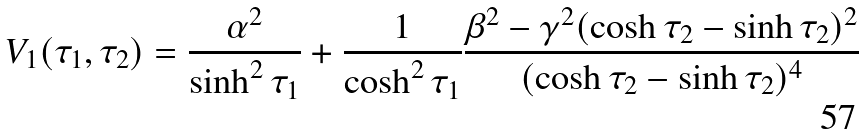Convert formula to latex. <formula><loc_0><loc_0><loc_500><loc_500>V _ { 1 } ( \tau _ { 1 } , \tau _ { 2 } ) = \frac { \alpha ^ { 2 } } { \sinh ^ { 2 } \tau _ { 1 } } + \frac { 1 } { \cosh ^ { 2 } \tau _ { 1 } } \frac { \beta ^ { 2 } - \gamma ^ { 2 } ( \cosh \tau _ { 2 } - \sinh \tau _ { 2 } ) ^ { 2 } } { ( \cosh \tau _ { 2 } - \sinh \tau _ { 2 } ) ^ { 4 } }</formula> 